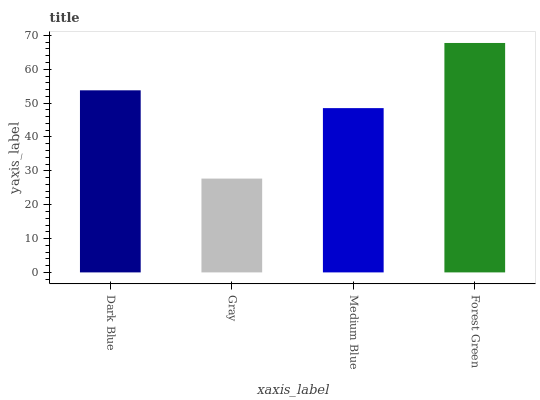Is Gray the minimum?
Answer yes or no. Yes. Is Forest Green the maximum?
Answer yes or no. Yes. Is Medium Blue the minimum?
Answer yes or no. No. Is Medium Blue the maximum?
Answer yes or no. No. Is Medium Blue greater than Gray?
Answer yes or no. Yes. Is Gray less than Medium Blue?
Answer yes or no. Yes. Is Gray greater than Medium Blue?
Answer yes or no. No. Is Medium Blue less than Gray?
Answer yes or no. No. Is Dark Blue the high median?
Answer yes or no. Yes. Is Medium Blue the low median?
Answer yes or no. Yes. Is Gray the high median?
Answer yes or no. No. Is Gray the low median?
Answer yes or no. No. 